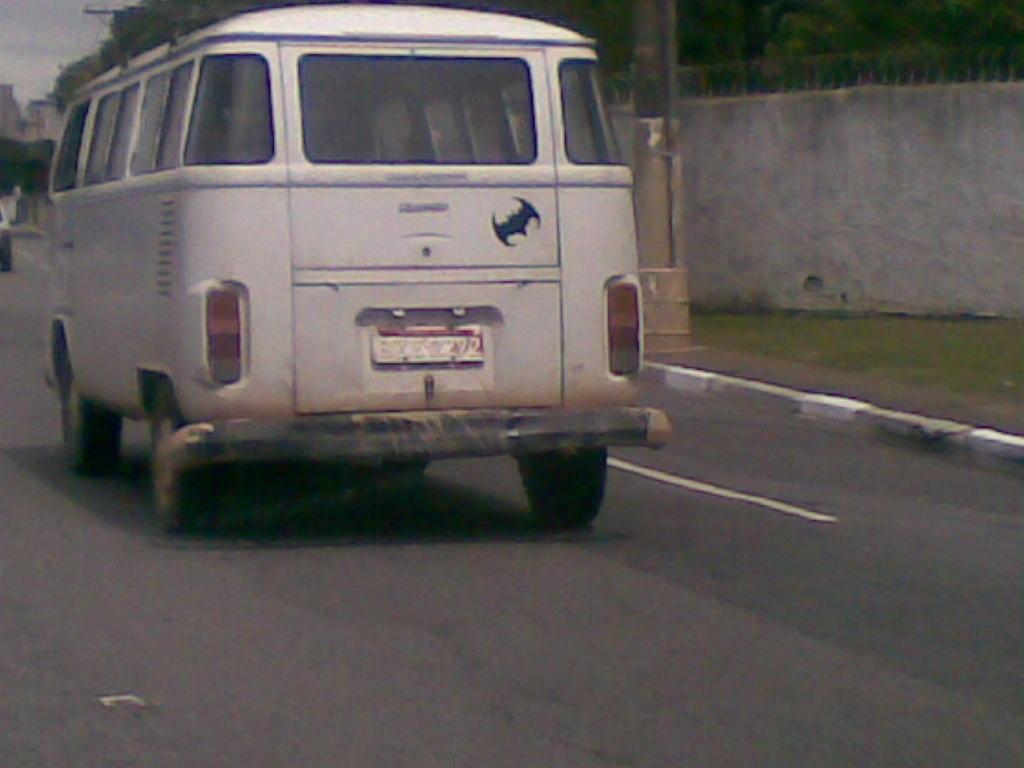What is the main subject of the image? There is a vehicle in the image. What color is the vehicle? The vehicle is white. What can be seen in the background of the image? There are trees and buildings in the background of the image. What color are the trees? The trees are green. What else is visible in the image? The sky is visible in the image. What color is the sky? The sky is white. Where is the lamp hanging in the image? There is no lamp present in the image. What type of cart is visible in the image? There is no cart present in the image. 